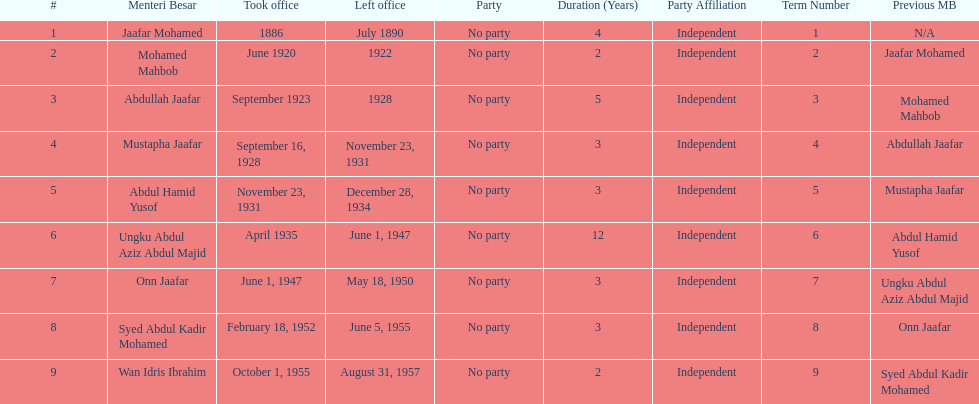Other than abullah jaafar, name someone with the same last name. Mustapha Jaafar. 